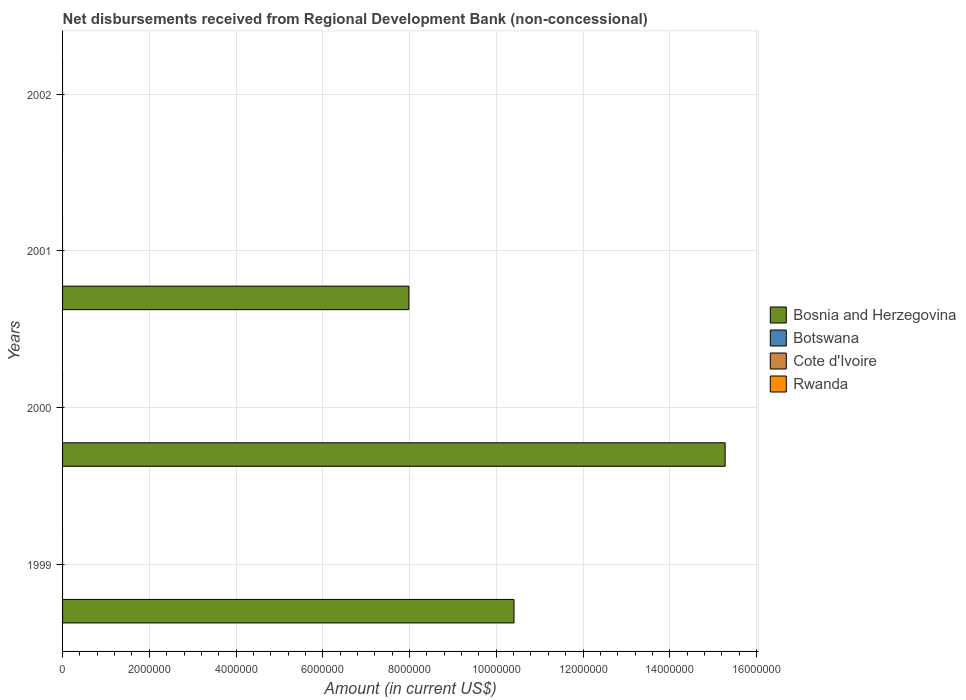How many bars are there on the 3rd tick from the top?
Ensure brevity in your answer.  1. How many bars are there on the 3rd tick from the bottom?
Your response must be concise. 1. In how many cases, is the number of bars for a given year not equal to the number of legend labels?
Your answer should be compact. 4. What is the amount of disbursements received from Regional Development Bank in Botswana in 1999?
Your answer should be very brief. 0. Across all years, what is the minimum amount of disbursements received from Regional Development Bank in Bosnia and Herzegovina?
Your response must be concise. 0. What is the total amount of disbursements received from Regional Development Bank in Rwanda in the graph?
Your answer should be very brief. 0. What is the difference between the highest and the second highest amount of disbursements received from Regional Development Bank in Bosnia and Herzegovina?
Provide a short and direct response. 4.87e+06. What is the difference between the highest and the lowest amount of disbursements received from Regional Development Bank in Bosnia and Herzegovina?
Provide a succinct answer. 1.53e+07. Is the sum of the amount of disbursements received from Regional Development Bank in Bosnia and Herzegovina in 2000 and 2001 greater than the maximum amount of disbursements received from Regional Development Bank in Rwanda across all years?
Offer a terse response. Yes. Is it the case that in every year, the sum of the amount of disbursements received from Regional Development Bank in Cote d'Ivoire and amount of disbursements received from Regional Development Bank in Botswana is greater than the sum of amount of disbursements received from Regional Development Bank in Bosnia and Herzegovina and amount of disbursements received from Regional Development Bank in Rwanda?
Provide a succinct answer. No. How many years are there in the graph?
Provide a short and direct response. 4. Are the values on the major ticks of X-axis written in scientific E-notation?
Make the answer very short. No. Where does the legend appear in the graph?
Make the answer very short. Center right. How are the legend labels stacked?
Your answer should be very brief. Vertical. What is the title of the graph?
Keep it short and to the point. Net disbursements received from Regional Development Bank (non-concessional). What is the label or title of the X-axis?
Offer a very short reply. Amount (in current US$). What is the Amount (in current US$) in Bosnia and Herzegovina in 1999?
Provide a succinct answer. 1.04e+07. What is the Amount (in current US$) of Botswana in 1999?
Ensure brevity in your answer.  0. What is the Amount (in current US$) of Rwanda in 1999?
Make the answer very short. 0. What is the Amount (in current US$) of Bosnia and Herzegovina in 2000?
Offer a very short reply. 1.53e+07. What is the Amount (in current US$) in Cote d'Ivoire in 2000?
Your response must be concise. 0. What is the Amount (in current US$) of Rwanda in 2000?
Offer a terse response. 0. What is the Amount (in current US$) of Bosnia and Herzegovina in 2001?
Your answer should be very brief. 7.99e+06. What is the Amount (in current US$) of Botswana in 2001?
Keep it short and to the point. 0. Across all years, what is the maximum Amount (in current US$) of Bosnia and Herzegovina?
Offer a terse response. 1.53e+07. What is the total Amount (in current US$) in Bosnia and Herzegovina in the graph?
Ensure brevity in your answer.  3.37e+07. What is the total Amount (in current US$) in Botswana in the graph?
Give a very brief answer. 0. What is the total Amount (in current US$) in Rwanda in the graph?
Your response must be concise. 0. What is the difference between the Amount (in current US$) in Bosnia and Herzegovina in 1999 and that in 2000?
Your answer should be very brief. -4.87e+06. What is the difference between the Amount (in current US$) of Bosnia and Herzegovina in 1999 and that in 2001?
Your answer should be compact. 2.42e+06. What is the difference between the Amount (in current US$) in Bosnia and Herzegovina in 2000 and that in 2001?
Make the answer very short. 7.29e+06. What is the average Amount (in current US$) of Bosnia and Herzegovina per year?
Make the answer very short. 8.42e+06. What is the ratio of the Amount (in current US$) in Bosnia and Herzegovina in 1999 to that in 2000?
Keep it short and to the point. 0.68. What is the ratio of the Amount (in current US$) of Bosnia and Herzegovina in 1999 to that in 2001?
Offer a very short reply. 1.3. What is the ratio of the Amount (in current US$) of Bosnia and Herzegovina in 2000 to that in 2001?
Provide a short and direct response. 1.91. What is the difference between the highest and the second highest Amount (in current US$) in Bosnia and Herzegovina?
Provide a succinct answer. 4.87e+06. What is the difference between the highest and the lowest Amount (in current US$) of Bosnia and Herzegovina?
Provide a succinct answer. 1.53e+07. 